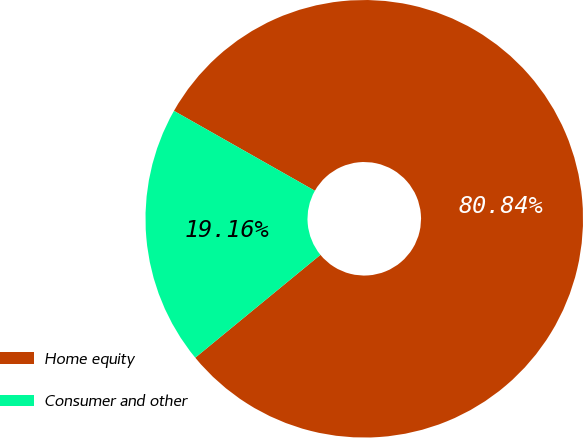Convert chart to OTSL. <chart><loc_0><loc_0><loc_500><loc_500><pie_chart><fcel>Home equity<fcel>Consumer and other<nl><fcel>80.84%<fcel>19.16%<nl></chart> 